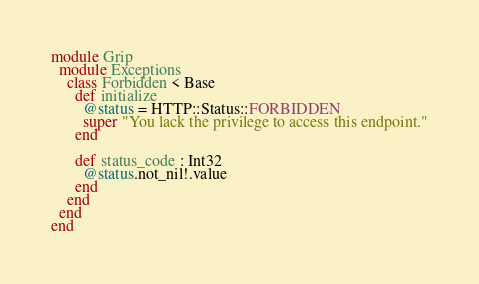Convert code to text. <code><loc_0><loc_0><loc_500><loc_500><_Crystal_>module Grip
  module Exceptions
    class Forbidden < Base
      def initialize
        @status = HTTP::Status::FORBIDDEN
        super "You lack the privilege to access this endpoint."
      end

      def status_code : Int32
        @status.not_nil!.value
      end
    end
  end
end
</code> 